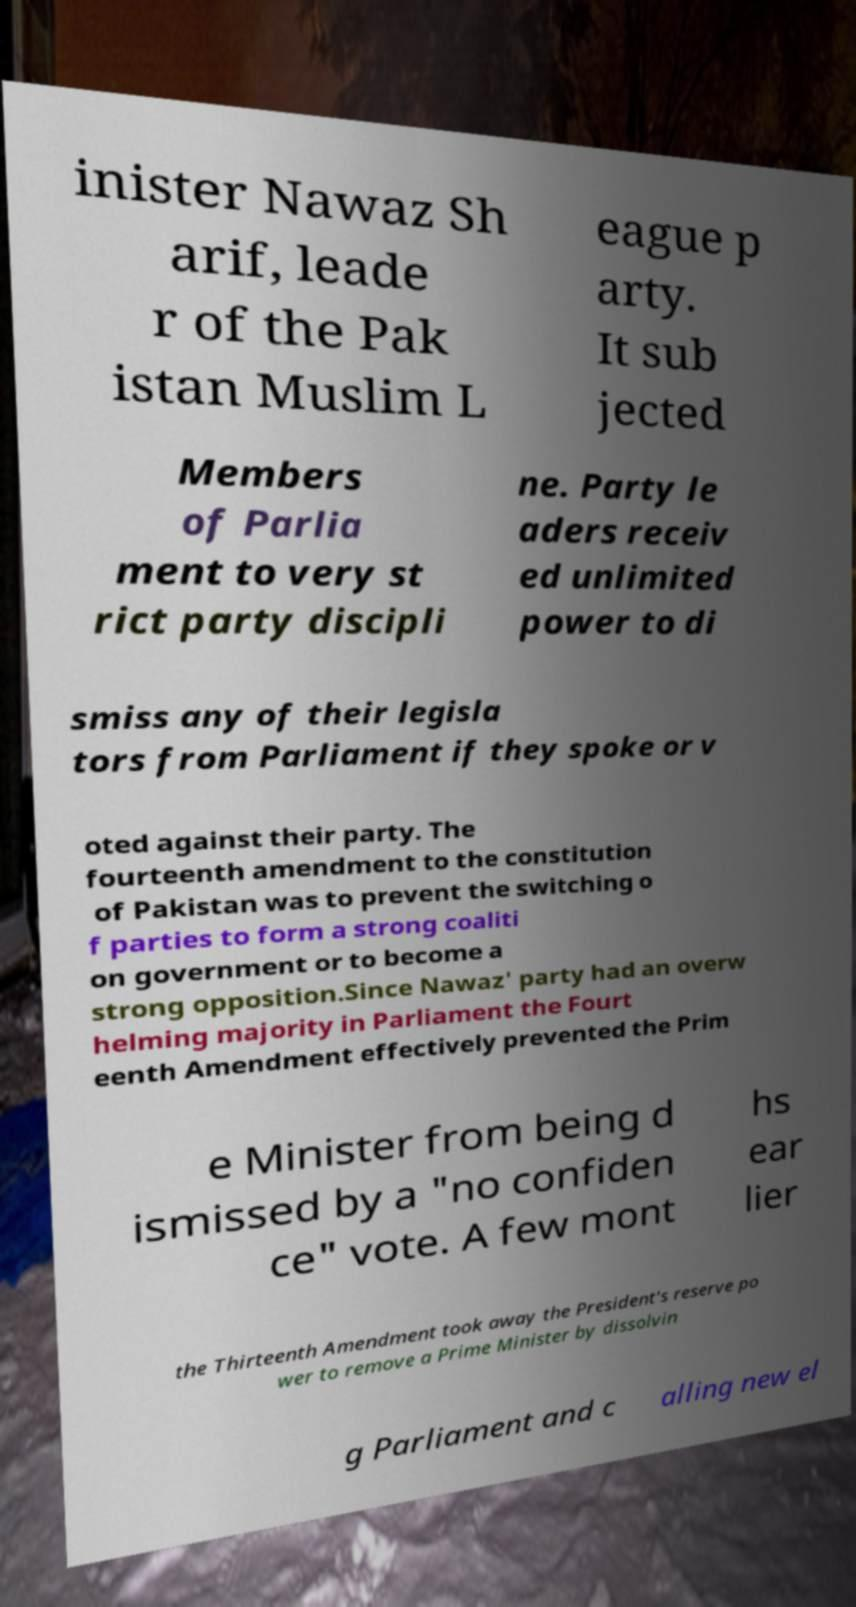What messages or text are displayed in this image? I need them in a readable, typed format. inister Nawaz Sh arif, leade r of the Pak istan Muslim L eague p arty. It sub jected Members of Parlia ment to very st rict party discipli ne. Party le aders receiv ed unlimited power to di smiss any of their legisla tors from Parliament if they spoke or v oted against their party. The fourteenth amendment to the constitution of Pakistan was to prevent the switching o f parties to form a strong coaliti on government or to become a strong opposition.Since Nawaz' party had an overw helming majority in Parliament the Fourt eenth Amendment effectively prevented the Prim e Minister from being d ismissed by a "no confiden ce" vote. A few mont hs ear lier the Thirteenth Amendment took away the President's reserve po wer to remove a Prime Minister by dissolvin g Parliament and c alling new el 